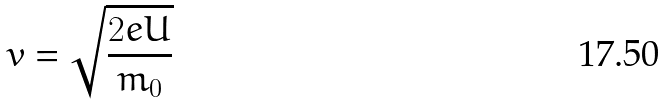<formula> <loc_0><loc_0><loc_500><loc_500>v = \sqrt { \frac { 2 e U } { m _ { 0 } } }</formula> 